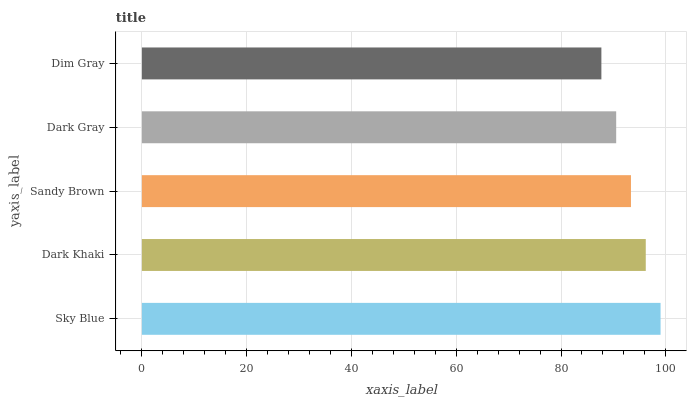Is Dim Gray the minimum?
Answer yes or no. Yes. Is Sky Blue the maximum?
Answer yes or no. Yes. Is Dark Khaki the minimum?
Answer yes or no. No. Is Dark Khaki the maximum?
Answer yes or no. No. Is Sky Blue greater than Dark Khaki?
Answer yes or no. Yes. Is Dark Khaki less than Sky Blue?
Answer yes or no. Yes. Is Dark Khaki greater than Sky Blue?
Answer yes or no. No. Is Sky Blue less than Dark Khaki?
Answer yes or no. No. Is Sandy Brown the high median?
Answer yes or no. Yes. Is Sandy Brown the low median?
Answer yes or no. Yes. Is Dim Gray the high median?
Answer yes or no. No. Is Dark Khaki the low median?
Answer yes or no. No. 